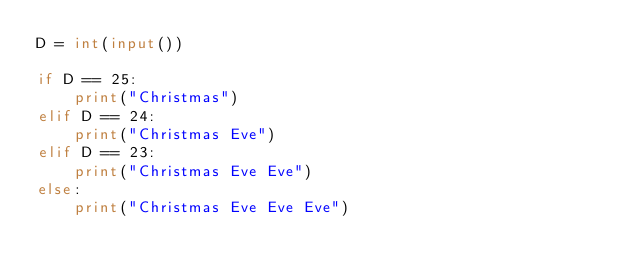<code> <loc_0><loc_0><loc_500><loc_500><_Python_>D = int(input())

if D == 25:
    print("Christmas")
elif D == 24:
    print("Christmas Eve")
elif D == 23:
    print("Christmas Eve Eve")
else:
    print("Christmas Eve Eve Eve")</code> 